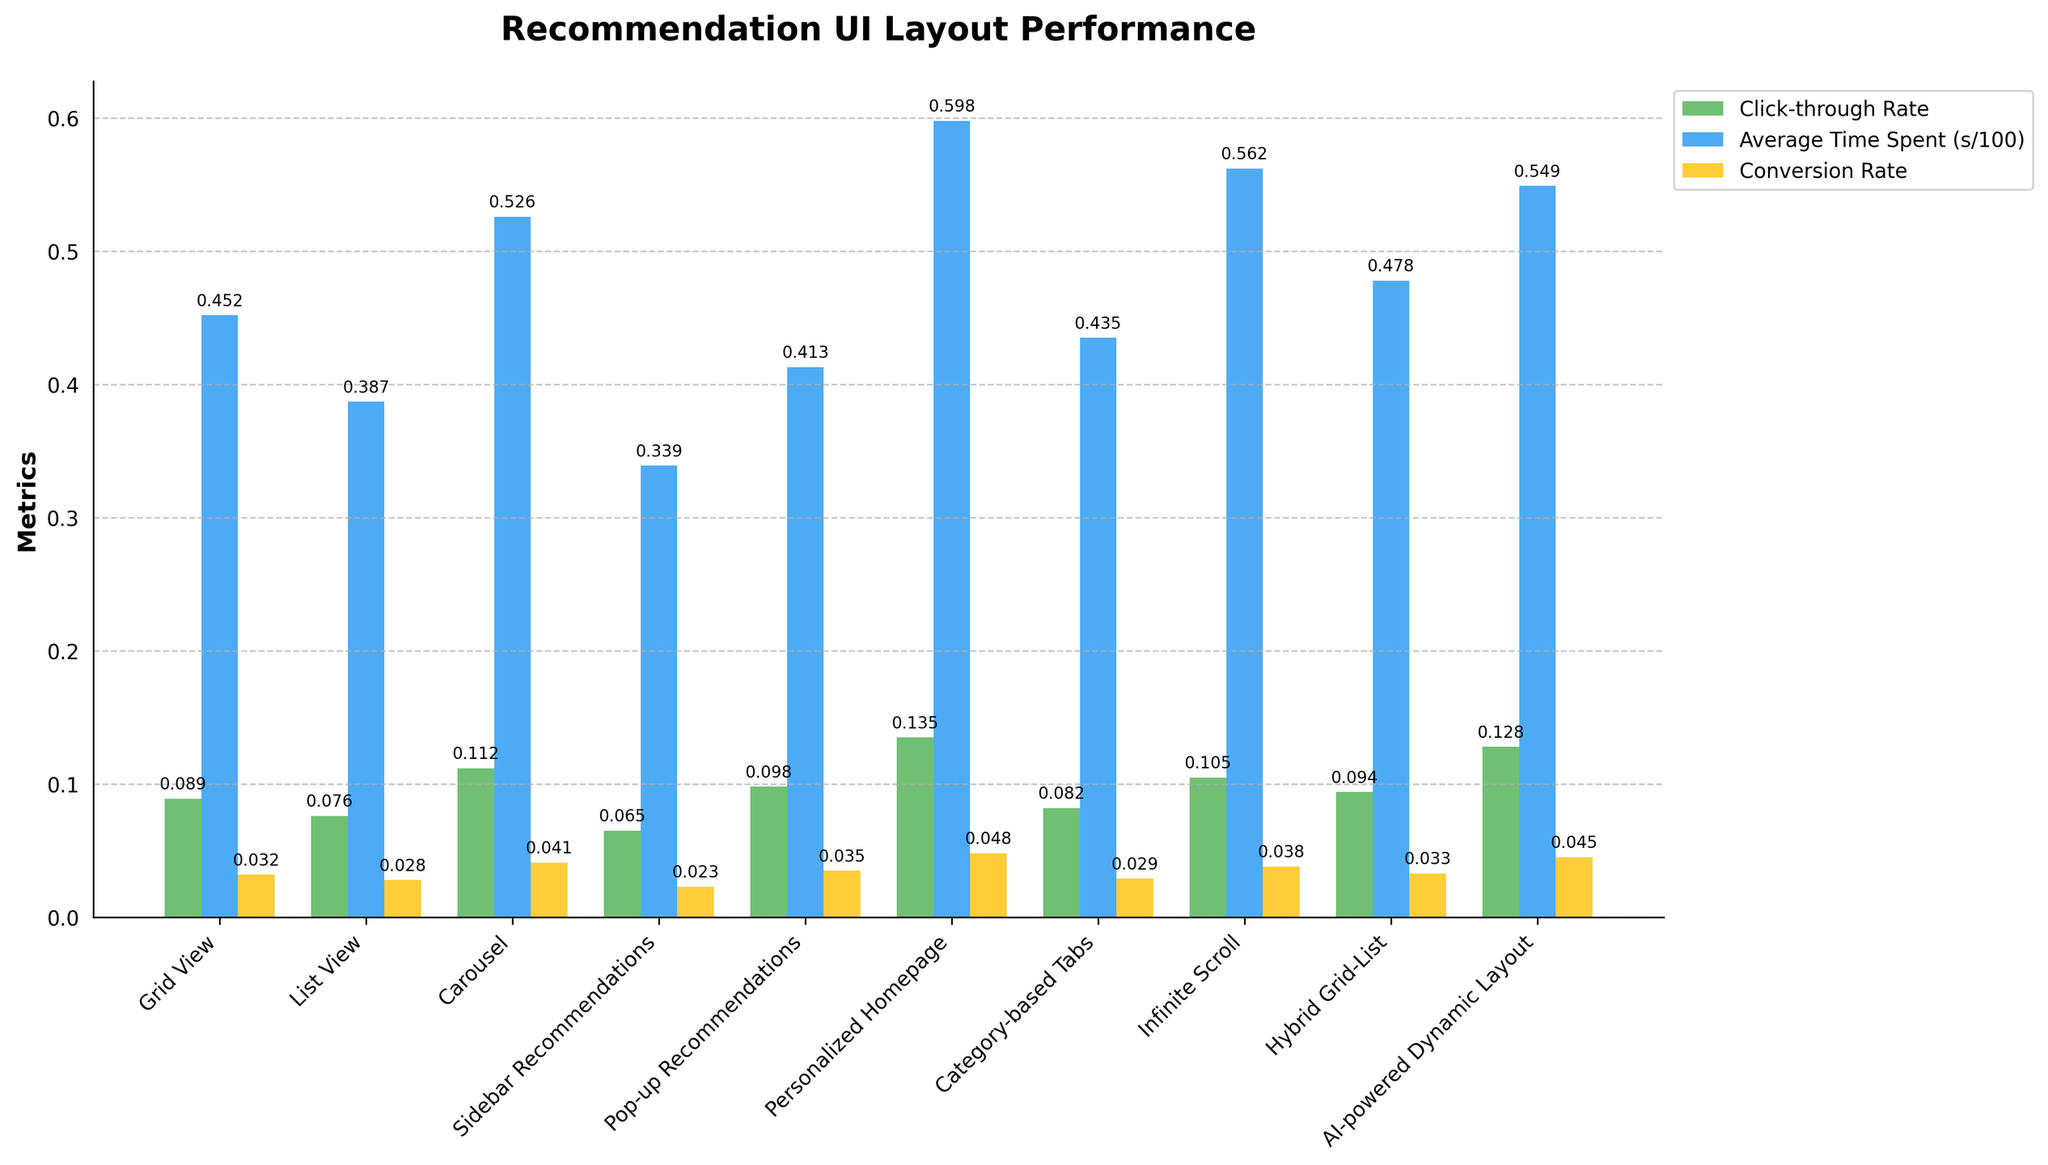What's the click-through rate for the "AI-powered Dynamic Layout"? Look at the bar labeled "AI-powered Dynamic Layout" in the chart. The green bar represents the click-through rate. The value attached to this bar is the click-through rate.
Answer: 0.128 Which layout has the highest conversion rate? Identify the conversion rate in the figure by looking at the yellow bars. Look at the corresponding layout label of the tallest yellow bar.
Answer: Personalized Homepage How much more average time is spent on "Infinite Scroll" compared to "List View"? Locate the bars for "Infinite Scroll" and "List View" which represent average time spent (blue bars). Calculate the difference by subtracting the average time spent on "List View" from "Infinite Scroll."
Answer: 17.5 seconds Compare the click-through rate of "Grid View" to "Sidebar Recommendations" and state which is higher. Identify the green bars corresponding to "Grid View" and "Sidebar Recommendations." Compare the heights of these two bars and state which has the higher value.
Answer: Grid View What is the combined click-through rate for "Carousel" and "Pop-up Recommendations"? Look at the green bars for "Carousel" and "Pop-up Recommendations." Add the numeric values associated with these bars together.
Answer: 0.21 Determine if "AI-powered Dynamic Layout" has a higher conversion rate than "Hybrid Grid-List." Identify the yellow bars for "AI-powered Dynamic Layout" and "Hybrid Grid-List." Compare the heights of the two bars to see which is higher.
Answer: Yes Between "List View" and "Category-based Tabs," which has the lower average time spent? Check the blue bars representing average time spent for both "List View" and "Category-based Tabs." Determine which bar is shorter.
Answer: List View What's the average click-through rate across all layouts? Find all the green bars representing the click-through rate for each layout. Add all these values and divide by the number of layouts (10) to find the average.
Answer: 0.0988 What's the difference in the conversion rate between the layout with the highest rate and the one with the lowest rate? Locate the highest and lowest yellow bars representing the conversion rate. Subtract the value of the lowest conversion rate from the highest conversion rate.
Answer: 0.025 Which layout has the closest average time spent to 50 seconds? Check the blue bars representing average time spent for each layout. Find the bar height closest to the 50-second mark.
Answer: Carousel 